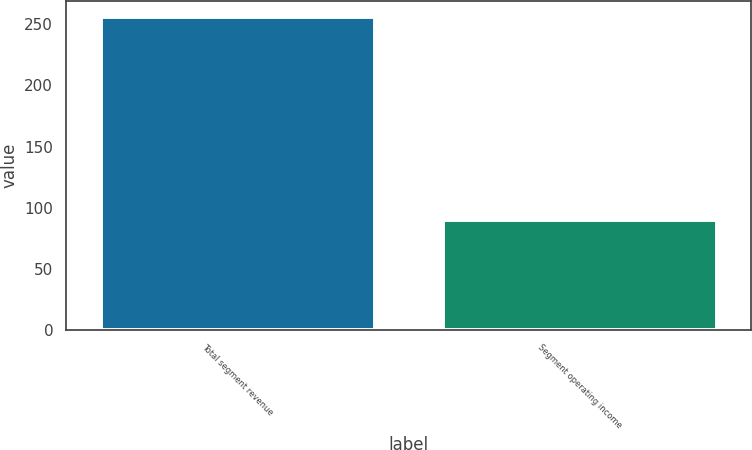Convert chart. <chart><loc_0><loc_0><loc_500><loc_500><bar_chart><fcel>Total segment revenue<fcel>Segment operating income<nl><fcel>256<fcel>90<nl></chart> 